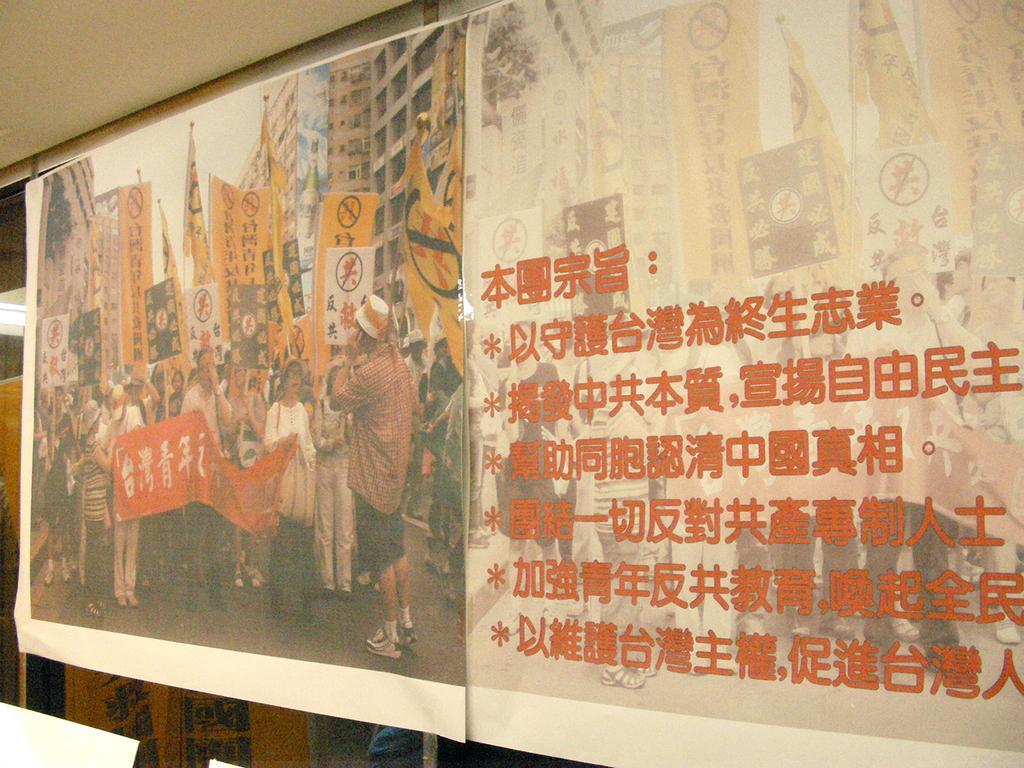Could you give a brief overview of what you see in this image? In this picture, we see the banners of the posters containing the image of the people who are standing on the road. Most of them are holding the flags and the boards in yellow color. We see some text written on it. In front of the image, we see the people are holding a red color sheet with some text written. Behind them, there are many buildings. On the right side, we see some text written in different language. At the bottom, we see an object or a board in yellow color. At the top, we see the roof of the building. 